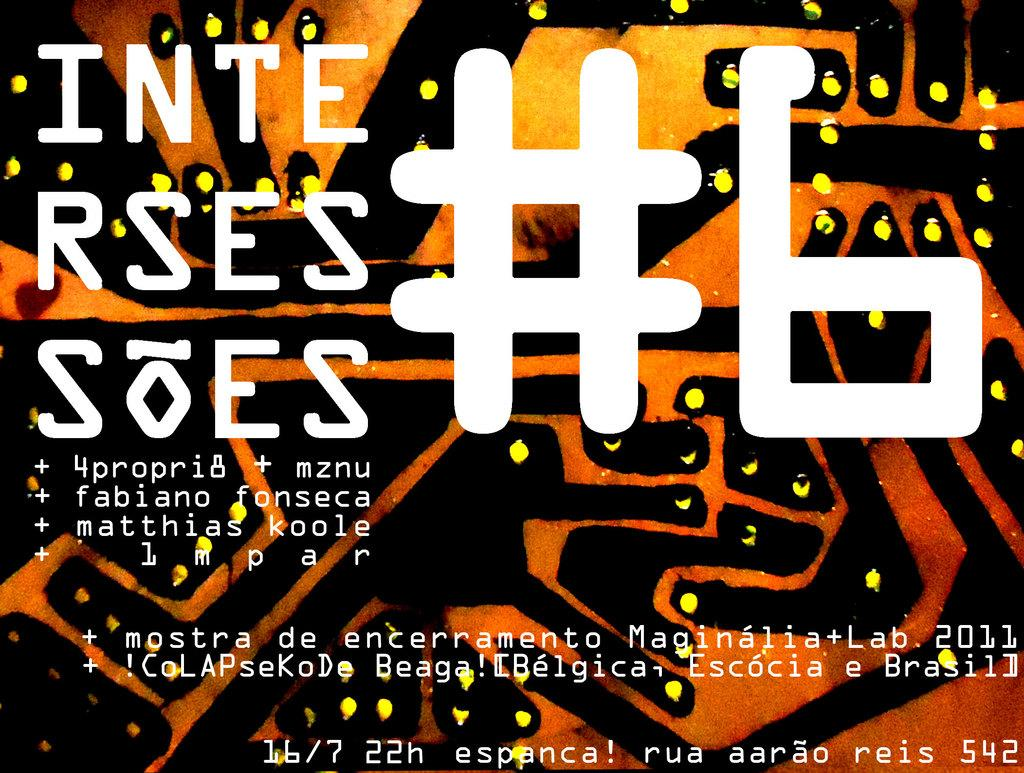<image>
Share a concise interpretation of the image provided. A black and orange image has #6 in white. 